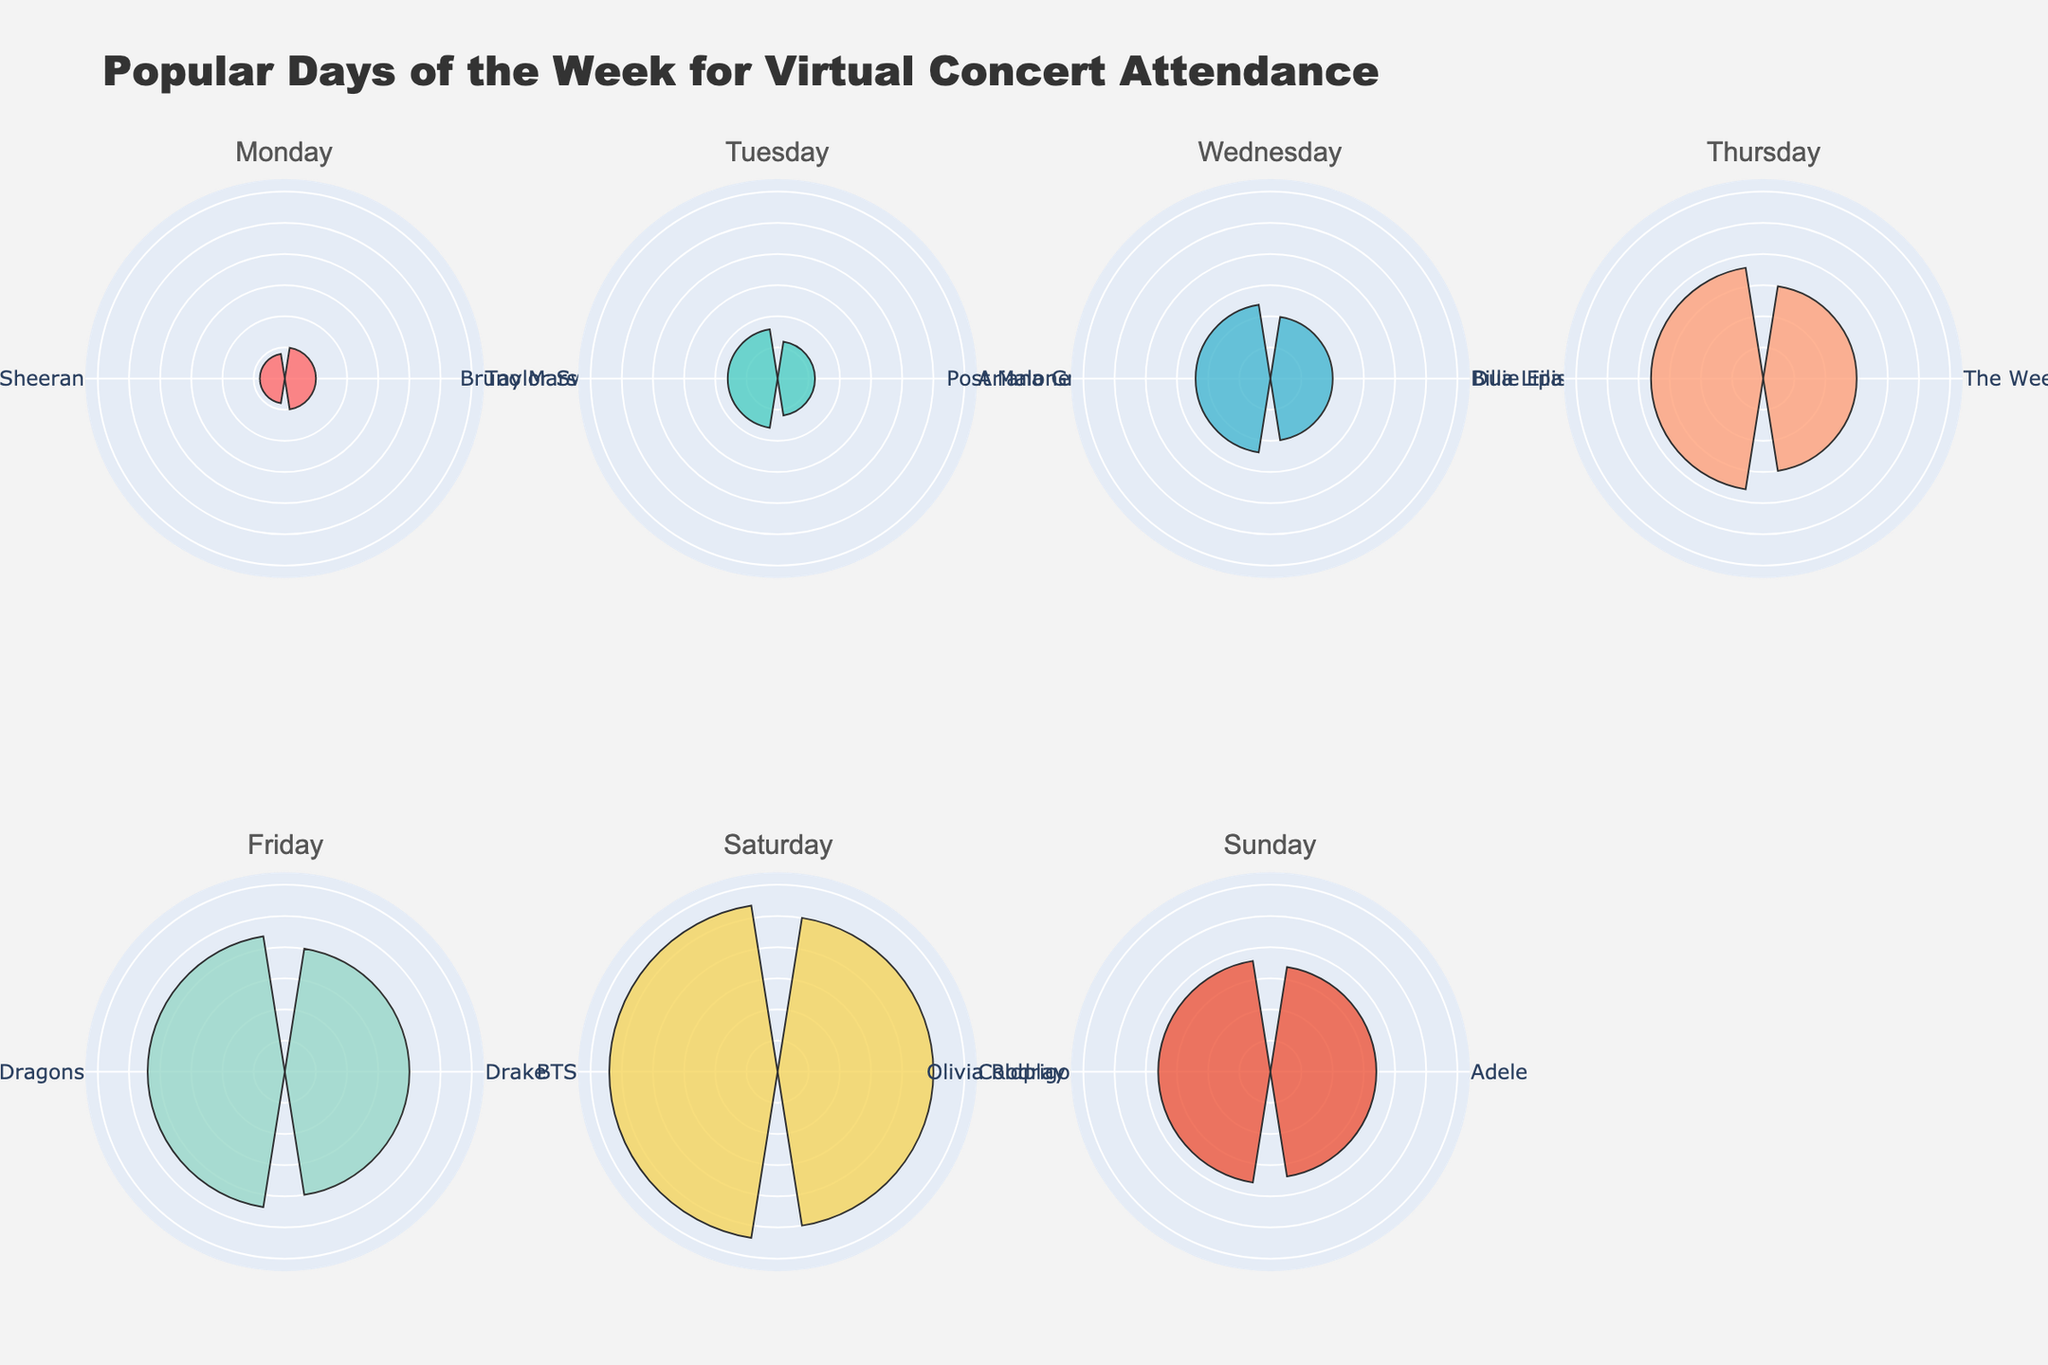what is the most popular day for virtual concert attendance? By looking at each subplot, we can see the attendance percentage for each day. The subplots for 'Saturday' show attendance percentages of 25% for Coldplay and 27% for BTS. The highest attendance percentage is on Saturday (27%).
Answer: Saturday Which artist has the highest attendance percentage overall? Looking across all rose charts, we find the highest radial bar in the Saturday subplot for BTS with an attendance percentage of 27%.
Answer: BTS On which day does The Weeknd have a virtual concert, and what is the attendance percentage? Referring to the subplot for each day of the week, The Weeknd's data appears in the Thursday subplot with an attendance percentage of 15%.
Answer: Thursday, 15% How does the attendance percentage of Friday's concerts compare to those on Sunday? From the Friday subplot featuring Drake (20%) and Imagine Dragons (22%), and the Sunday subplot featuring Adele (17%) and Olivia Rodrigo (18%), we can determine that both artists on Friday have higher attendance percentages than those on Sunday.
Answer: Friday's concerts have higher attendance than Sunday's What is the total attendance percentage for virtual concerts on Wednesday? The Wednesday subplot shows Billie Eilish (10%) and Post Malone (12%), so the total attendance percentage for Wednesday is 10% + 12% = 22%.
Answer: 22% Which day has the least popular virtual concert attendance? The lowest attendance percentage appears for Monday’s subplot with Taylor Swift (5%) and Ed Sheeran (4%), making Monday the least popular day overall.
Answer: Monday Compare the attendance percentage of virtual concerts on Tuesday versus Thursday. On Tuesday, Ariana Grande has 6% and Bruno Mars has 8%, totaling 14%. On Thursday, The Weeknd has 15% and Dua Lipa has 18%, totaling 33%. Comparing the totals, Thursday has a higher attendance percentage than Tuesday.
Answer: Thursday has higher attendance What is the average attendance percentage for all the virtual concerts throughout the week? Sum all attendance percentages (5 + 4 + 6 + 8 + 10 + 12 + 15 + 18 + 20 + 22 + 25 + 27 + 17 + 18 = 207), divide by the number of artists (14), yielding an average attendance percentage of 207/14 ≈ 14.8%.
Answer: 14.8% On which day does Ariana Grande have her virtual concert, and is her attendance percentage higher or lower than Post Malone's? Ariana Grande is shown in the Tuesday subplot with an attendance percentage of 6%, while Post Malone is shown in the Wednesday subplot with 12%. Ariana Grande's attendance percentage is lower.
Answer: Tuesday, lower 